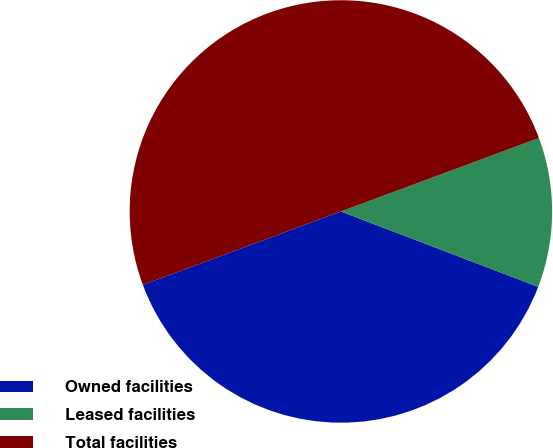Convert chart. <chart><loc_0><loc_0><loc_500><loc_500><pie_chart><fcel>Owned facilities<fcel>Leased facilities<fcel>Total facilities<nl><fcel>38.54%<fcel>11.46%<fcel>50.0%<nl></chart> 